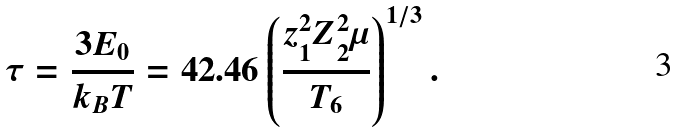Convert formula to latex. <formula><loc_0><loc_0><loc_500><loc_500>\tau = \frac { 3 E _ { 0 } } { k _ { B } T } = 4 2 . 4 6 \left ( \frac { z _ { 1 } ^ { 2 } Z _ { 2 } ^ { 2 } \mu } { T _ { 6 } } \right ) ^ { 1 / 3 } .</formula> 